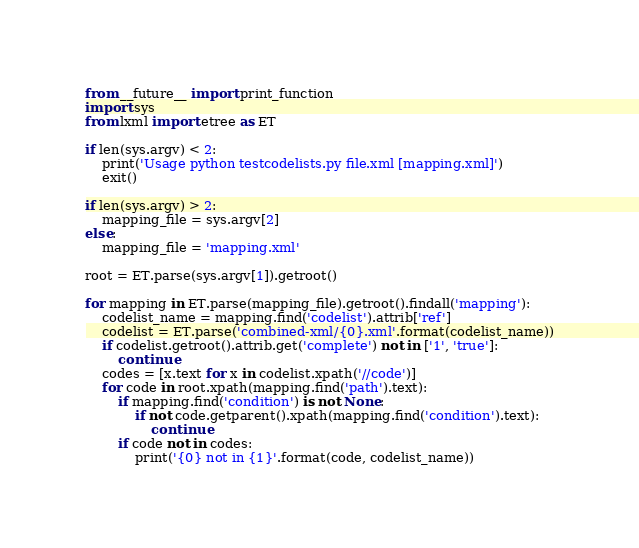Convert code to text. <code><loc_0><loc_0><loc_500><loc_500><_Python_>from __future__ import print_function
import sys
from lxml import etree as ET

if len(sys.argv) < 2:
    print('Usage python testcodelists.py file.xml [mapping.xml]')
    exit()

if len(sys.argv) > 2:
    mapping_file = sys.argv[2]
else:
    mapping_file = 'mapping.xml'

root = ET.parse(sys.argv[1]).getroot()

for mapping in ET.parse(mapping_file).getroot().findall('mapping'):
    codelist_name = mapping.find('codelist').attrib['ref']
    codelist = ET.parse('combined-xml/{0}.xml'.format(codelist_name))
    if codelist.getroot().attrib.get('complete') not in ['1', 'true']:
        continue
    codes = [x.text for x in codelist.xpath('//code')]
    for code in root.xpath(mapping.find('path').text):
        if mapping.find('condition') is not None:
            if not code.getparent().xpath(mapping.find('condition').text):
                continue
        if code not in codes:
            print('{0} not in {1}'.format(code, codelist_name))
</code> 